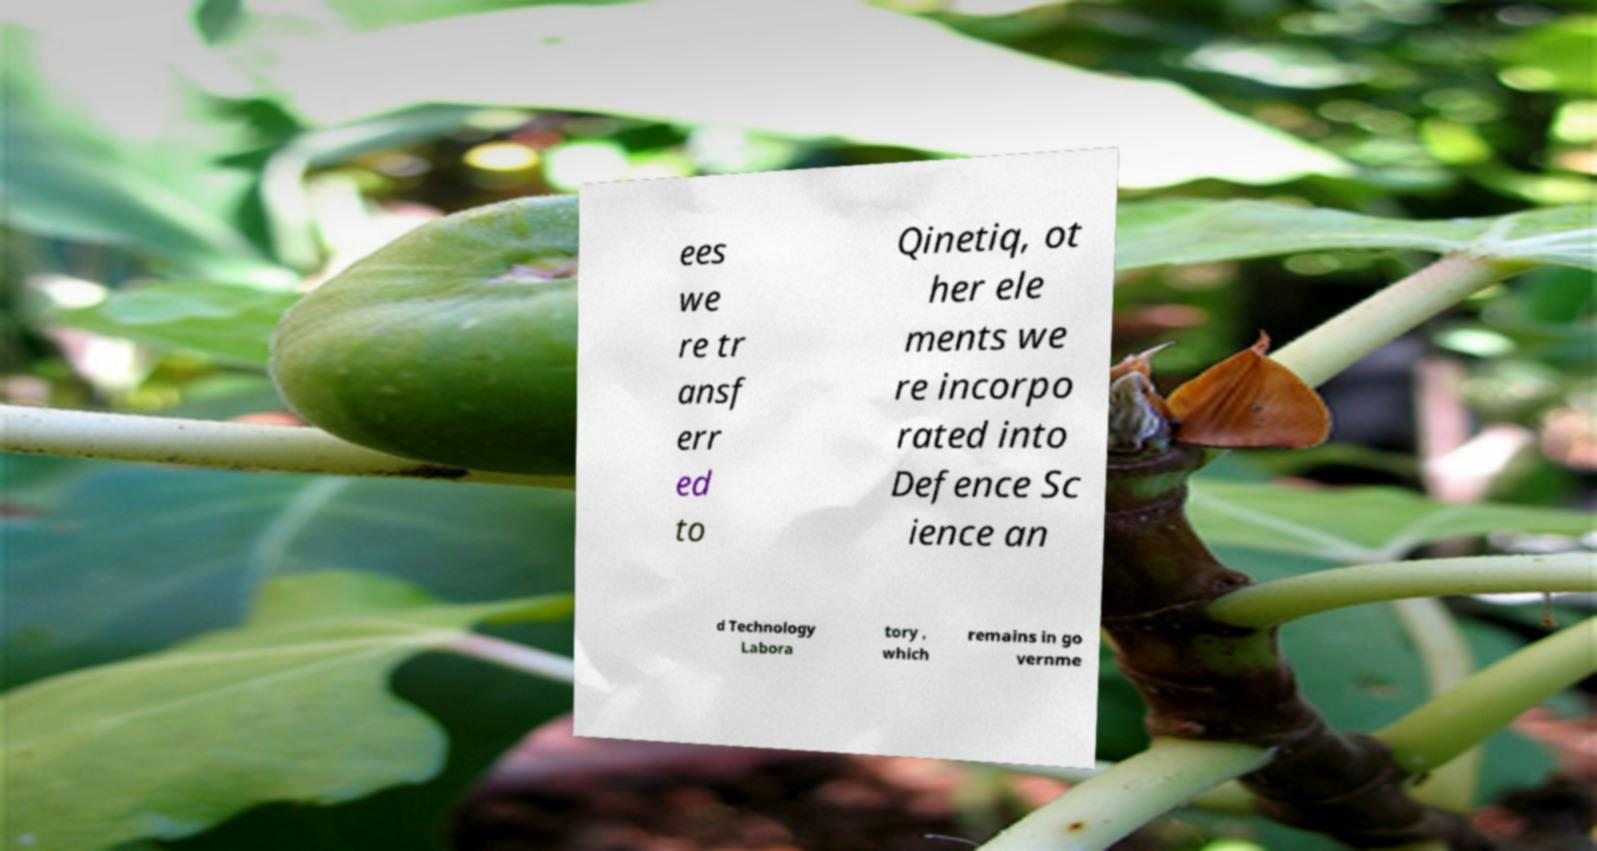Could you assist in decoding the text presented in this image and type it out clearly? ees we re tr ansf err ed to Qinetiq, ot her ele ments we re incorpo rated into Defence Sc ience an d Technology Labora tory , which remains in go vernme 